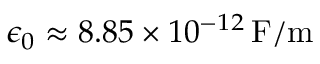<formula> <loc_0><loc_0><loc_500><loc_500>\epsilon _ { 0 } \approx 8 . 8 5 \times 1 0 ^ { - 1 2 } \, F / m</formula> 